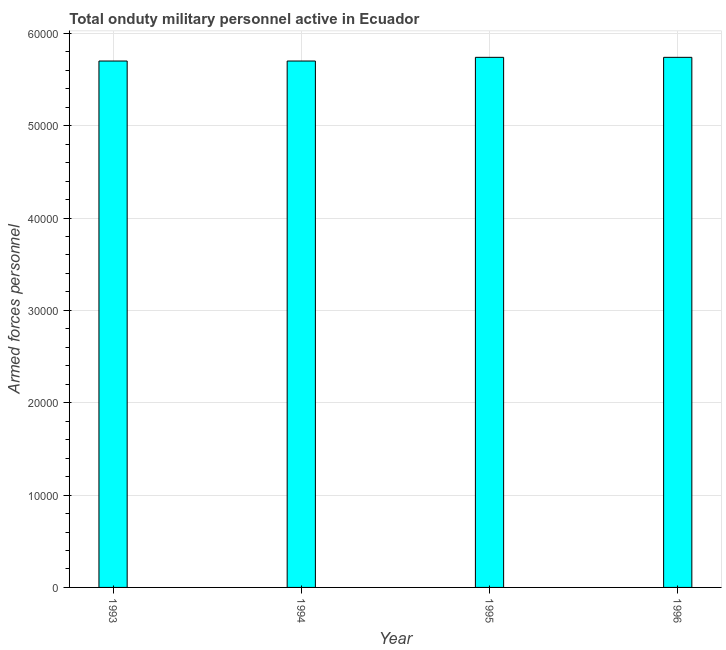What is the title of the graph?
Keep it short and to the point. Total onduty military personnel active in Ecuador. What is the label or title of the X-axis?
Give a very brief answer. Year. What is the label or title of the Y-axis?
Provide a succinct answer. Armed forces personnel. What is the number of armed forces personnel in 1993?
Offer a terse response. 5.70e+04. Across all years, what is the maximum number of armed forces personnel?
Your answer should be very brief. 5.74e+04. Across all years, what is the minimum number of armed forces personnel?
Provide a succinct answer. 5.70e+04. What is the sum of the number of armed forces personnel?
Offer a very short reply. 2.29e+05. What is the difference between the number of armed forces personnel in 1994 and 1995?
Provide a short and direct response. -400. What is the average number of armed forces personnel per year?
Keep it short and to the point. 5.72e+04. What is the median number of armed forces personnel?
Your response must be concise. 5.72e+04. In how many years, is the number of armed forces personnel greater than 38000 ?
Provide a short and direct response. 4. What is the difference between the highest and the second highest number of armed forces personnel?
Your answer should be very brief. 0. Is the sum of the number of armed forces personnel in 1994 and 1995 greater than the maximum number of armed forces personnel across all years?
Keep it short and to the point. Yes. In how many years, is the number of armed forces personnel greater than the average number of armed forces personnel taken over all years?
Your response must be concise. 2. What is the Armed forces personnel in 1993?
Make the answer very short. 5.70e+04. What is the Armed forces personnel of 1994?
Give a very brief answer. 5.70e+04. What is the Armed forces personnel in 1995?
Make the answer very short. 5.74e+04. What is the Armed forces personnel in 1996?
Give a very brief answer. 5.74e+04. What is the difference between the Armed forces personnel in 1993 and 1995?
Your answer should be very brief. -400. What is the difference between the Armed forces personnel in 1993 and 1996?
Your response must be concise. -400. What is the difference between the Armed forces personnel in 1994 and 1995?
Make the answer very short. -400. What is the difference between the Armed forces personnel in 1994 and 1996?
Your answer should be very brief. -400. What is the difference between the Armed forces personnel in 1995 and 1996?
Offer a very short reply. 0. What is the ratio of the Armed forces personnel in 1993 to that in 1994?
Provide a succinct answer. 1. What is the ratio of the Armed forces personnel in 1993 to that in 1995?
Give a very brief answer. 0.99. What is the ratio of the Armed forces personnel in 1993 to that in 1996?
Ensure brevity in your answer.  0.99. What is the ratio of the Armed forces personnel in 1995 to that in 1996?
Provide a succinct answer. 1. 